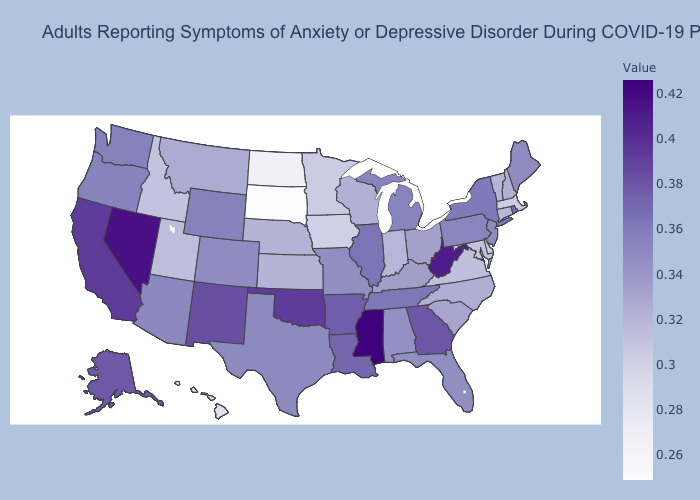Among the states that border Massachusetts , does Connecticut have the lowest value?
Keep it brief. Yes. Among the states that border Idaho , does Utah have the lowest value?
Give a very brief answer. Yes. Which states hav the highest value in the South?
Answer briefly. Mississippi. Does Mississippi have the highest value in the USA?
Be succinct. Yes. Does Illinois have the highest value in the MidWest?
Be succinct. Yes. Which states hav the highest value in the MidWest?
Keep it brief. Illinois. Among the states that border Florida , does Georgia have the lowest value?
Short answer required. No. 